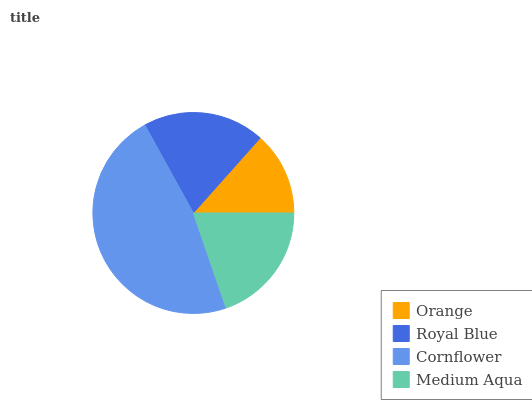Is Orange the minimum?
Answer yes or no. Yes. Is Cornflower the maximum?
Answer yes or no. Yes. Is Royal Blue the minimum?
Answer yes or no. No. Is Royal Blue the maximum?
Answer yes or no. No. Is Royal Blue greater than Orange?
Answer yes or no. Yes. Is Orange less than Royal Blue?
Answer yes or no. Yes. Is Orange greater than Royal Blue?
Answer yes or no. No. Is Royal Blue less than Orange?
Answer yes or no. No. Is Medium Aqua the high median?
Answer yes or no. Yes. Is Royal Blue the low median?
Answer yes or no. Yes. Is Cornflower the high median?
Answer yes or no. No. Is Orange the low median?
Answer yes or no. No. 